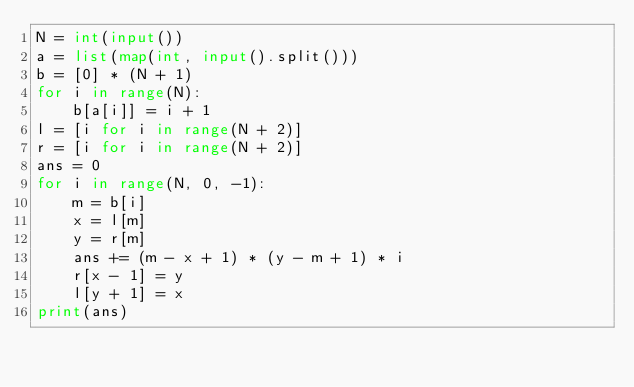Convert code to text. <code><loc_0><loc_0><loc_500><loc_500><_Python_>N = int(input())
a = list(map(int, input().split()))
b = [0] * (N + 1)
for i in range(N):
    b[a[i]] = i + 1
l = [i for i in range(N + 2)]
r = [i for i in range(N + 2)]
ans = 0
for i in range(N, 0, -1):
    m = b[i]
    x = l[m]
    y = r[m]
    ans += (m - x + 1) * (y - m + 1) * i
    r[x - 1] = y
    l[y + 1] = x
print(ans)</code> 